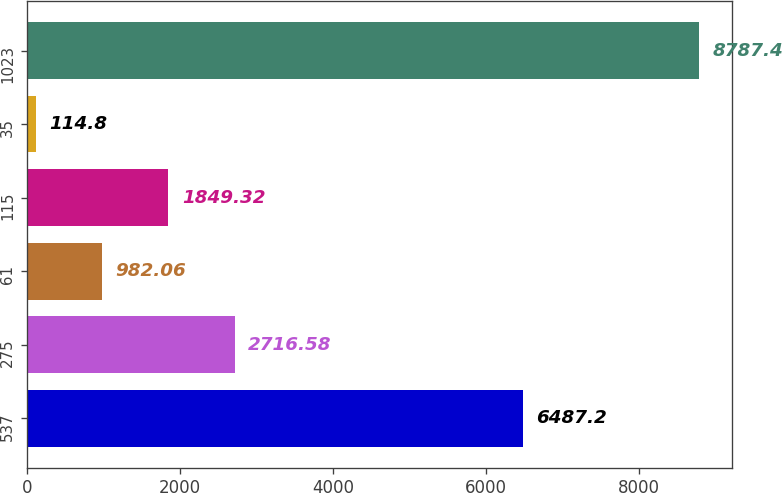<chart> <loc_0><loc_0><loc_500><loc_500><bar_chart><fcel>537<fcel>275<fcel>61<fcel>115<fcel>35<fcel>1023<nl><fcel>6487.2<fcel>2716.58<fcel>982.06<fcel>1849.32<fcel>114.8<fcel>8787.4<nl></chart> 